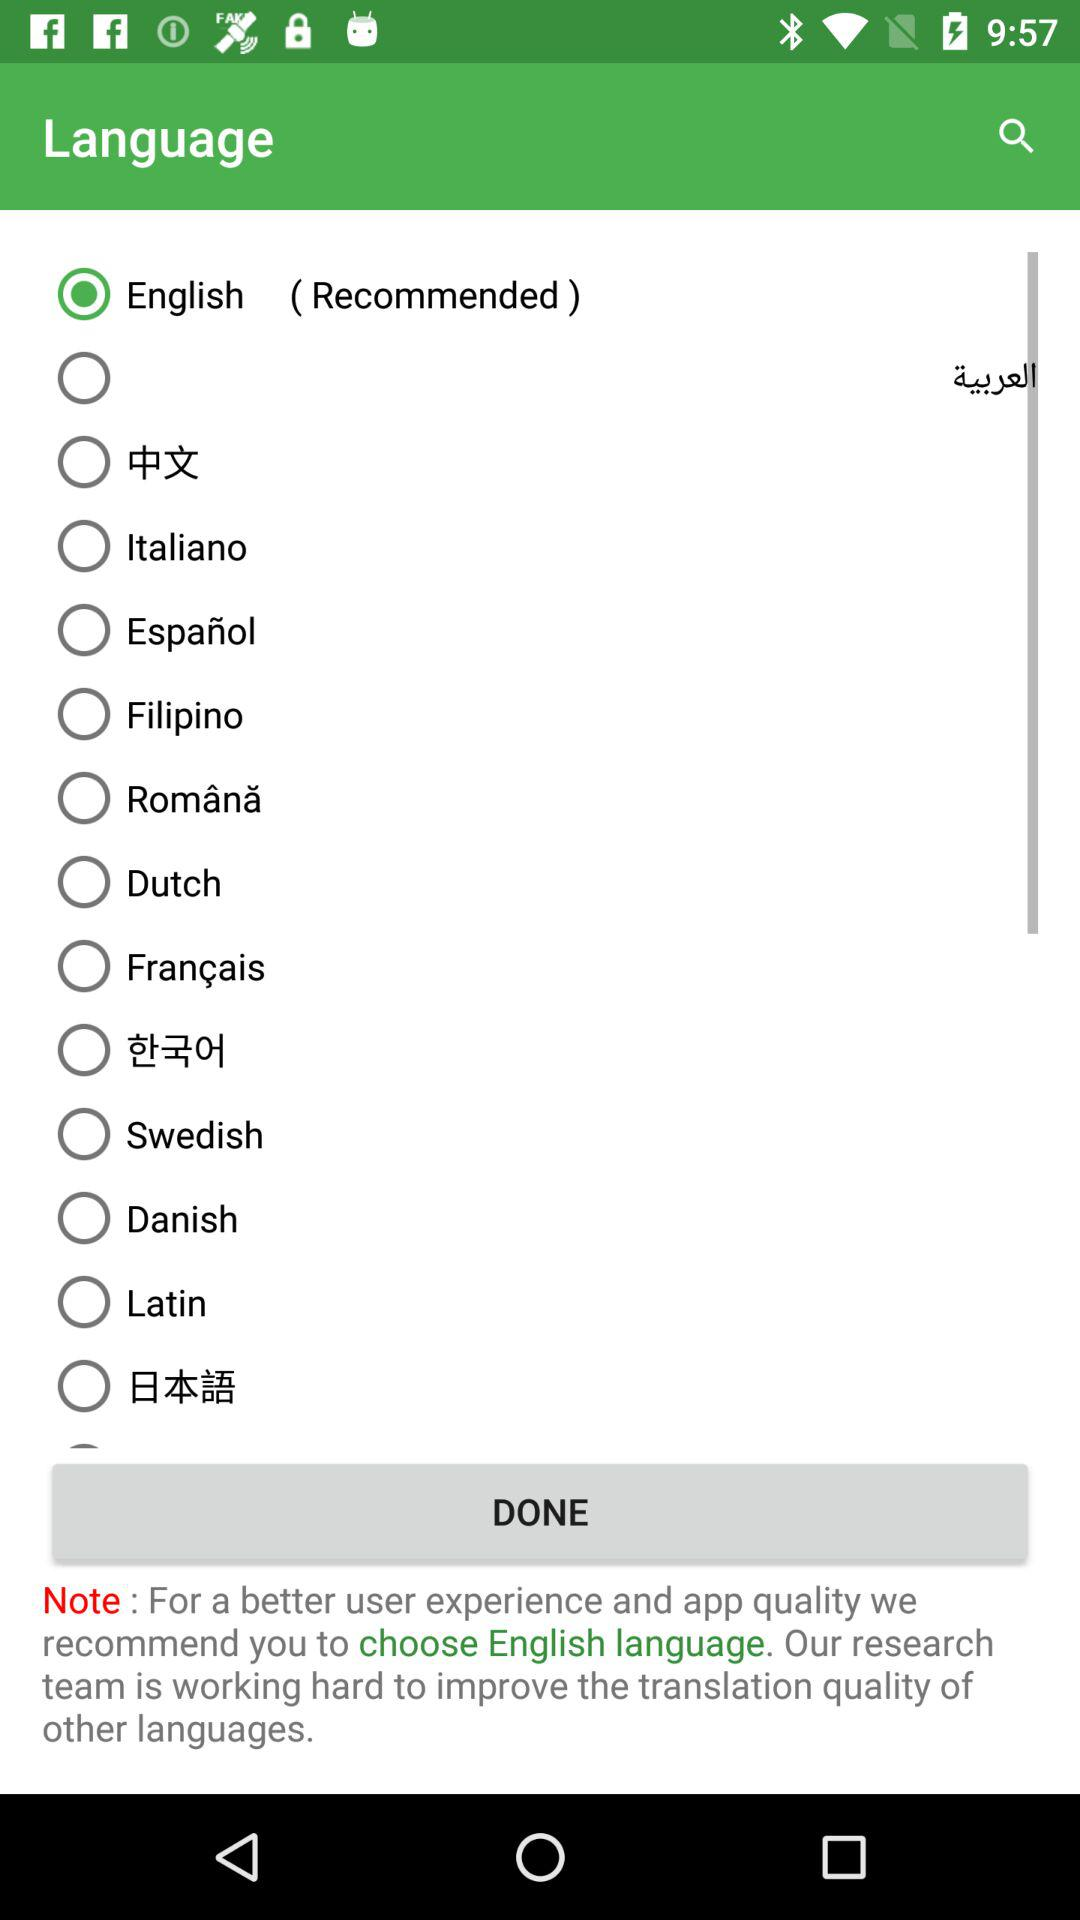What is the current status of "Dutch"? The status is "off". 